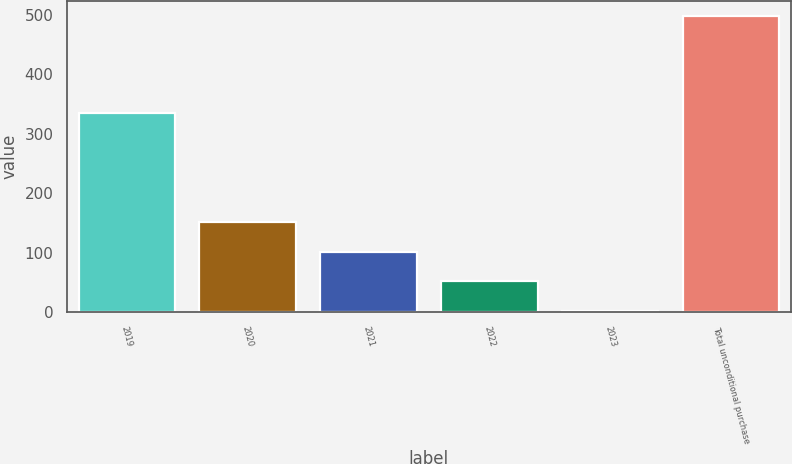<chart> <loc_0><loc_0><loc_500><loc_500><bar_chart><fcel>2019<fcel>2020<fcel>2021<fcel>2022<fcel>2023<fcel>Total unconditional purchase<nl><fcel>335<fcel>150.8<fcel>101.2<fcel>51.6<fcel>2<fcel>498<nl></chart> 